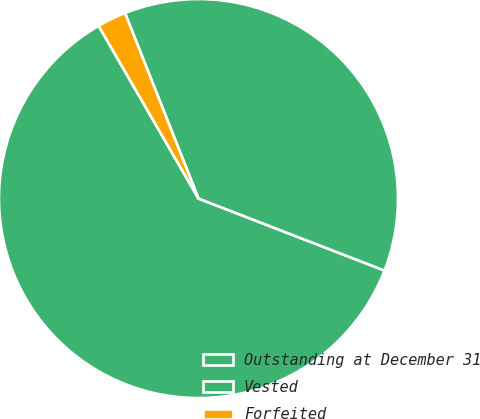<chart> <loc_0><loc_0><loc_500><loc_500><pie_chart><fcel>Outstanding at December 31<fcel>Vested<fcel>Forfeited<nl><fcel>60.78%<fcel>36.88%<fcel>2.34%<nl></chart> 